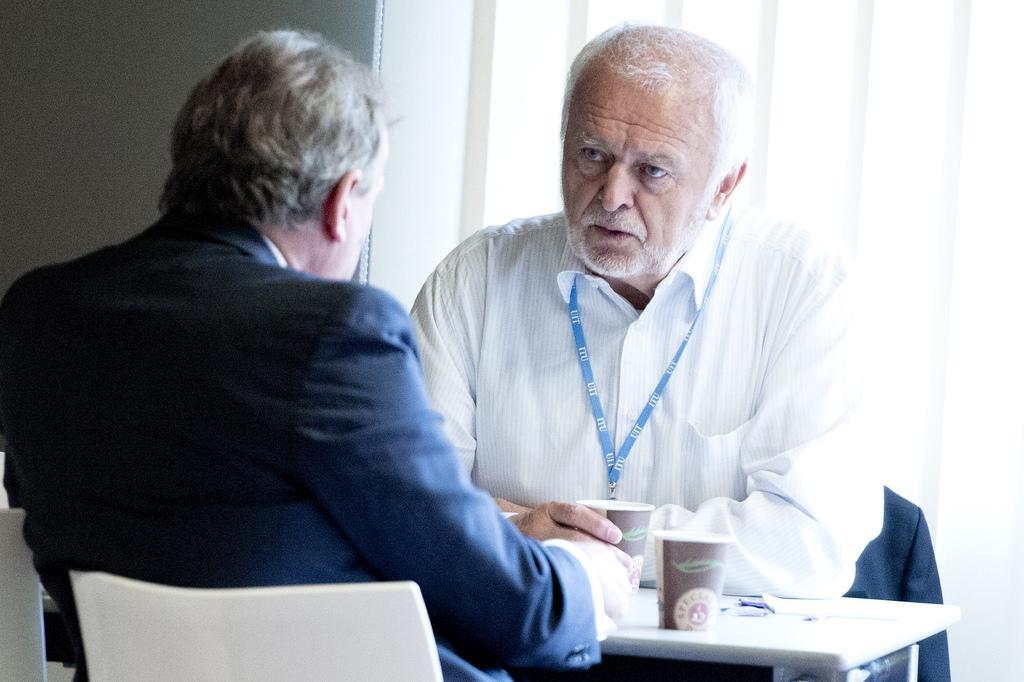Please provide a concise description of this image. In the bottom right corner of the image there is a table, on the table there are some cups. Surrounding the table two persons are sitting. Behind them there is wall. 